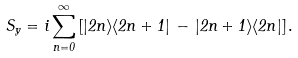Convert formula to latex. <formula><loc_0><loc_0><loc_500><loc_500>S _ { y } = i \sum _ { n = 0 } ^ { \infty } \left [ | 2 n \rangle \langle 2 n + 1 | \, - \, | 2 n + 1 \rangle \langle 2 n | \right ] .</formula> 